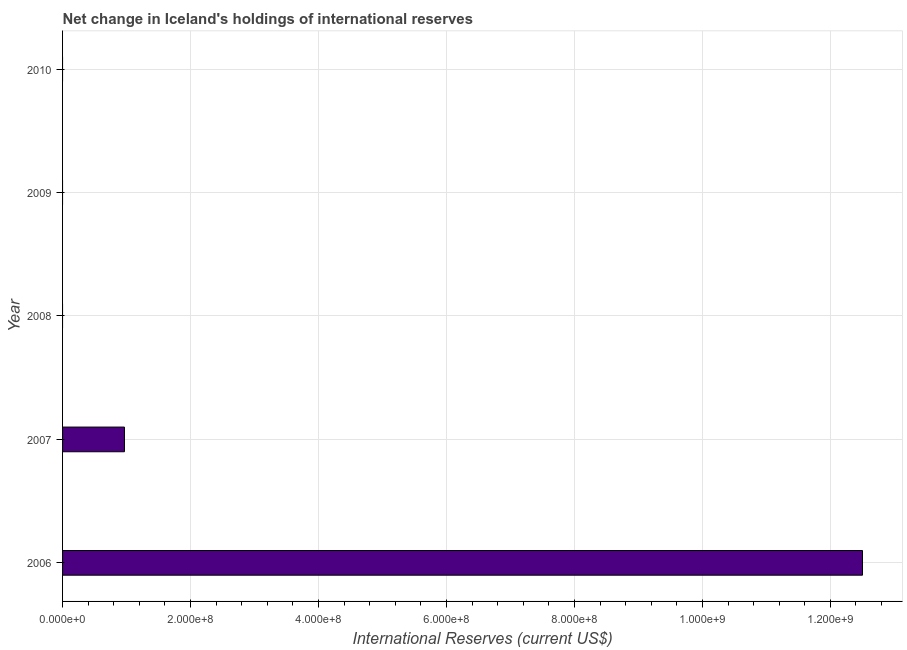Does the graph contain grids?
Your answer should be compact. Yes. What is the title of the graph?
Offer a terse response. Net change in Iceland's holdings of international reserves. What is the label or title of the X-axis?
Ensure brevity in your answer.  International Reserves (current US$). What is the reserves and related items in 2009?
Your response must be concise. 0. Across all years, what is the maximum reserves and related items?
Give a very brief answer. 1.25e+09. What is the sum of the reserves and related items?
Ensure brevity in your answer.  1.35e+09. What is the difference between the reserves and related items in 2006 and 2007?
Offer a terse response. 1.15e+09. What is the average reserves and related items per year?
Provide a succinct answer. 2.69e+08. In how many years, is the reserves and related items greater than 1200000000 US$?
Ensure brevity in your answer.  1. What is the ratio of the reserves and related items in 2006 to that in 2007?
Your answer should be very brief. 12.93. Is the reserves and related items in 2006 less than that in 2007?
Your answer should be very brief. No. What is the difference between the highest and the lowest reserves and related items?
Your answer should be very brief. 1.25e+09. Are the values on the major ticks of X-axis written in scientific E-notation?
Provide a short and direct response. Yes. What is the International Reserves (current US$) in 2006?
Give a very brief answer. 1.25e+09. What is the International Reserves (current US$) of 2007?
Offer a terse response. 9.67e+07. What is the International Reserves (current US$) in 2009?
Offer a very short reply. 0. What is the International Reserves (current US$) in 2010?
Provide a short and direct response. 0. What is the difference between the International Reserves (current US$) in 2006 and 2007?
Give a very brief answer. 1.15e+09. What is the ratio of the International Reserves (current US$) in 2006 to that in 2007?
Offer a terse response. 12.93. 